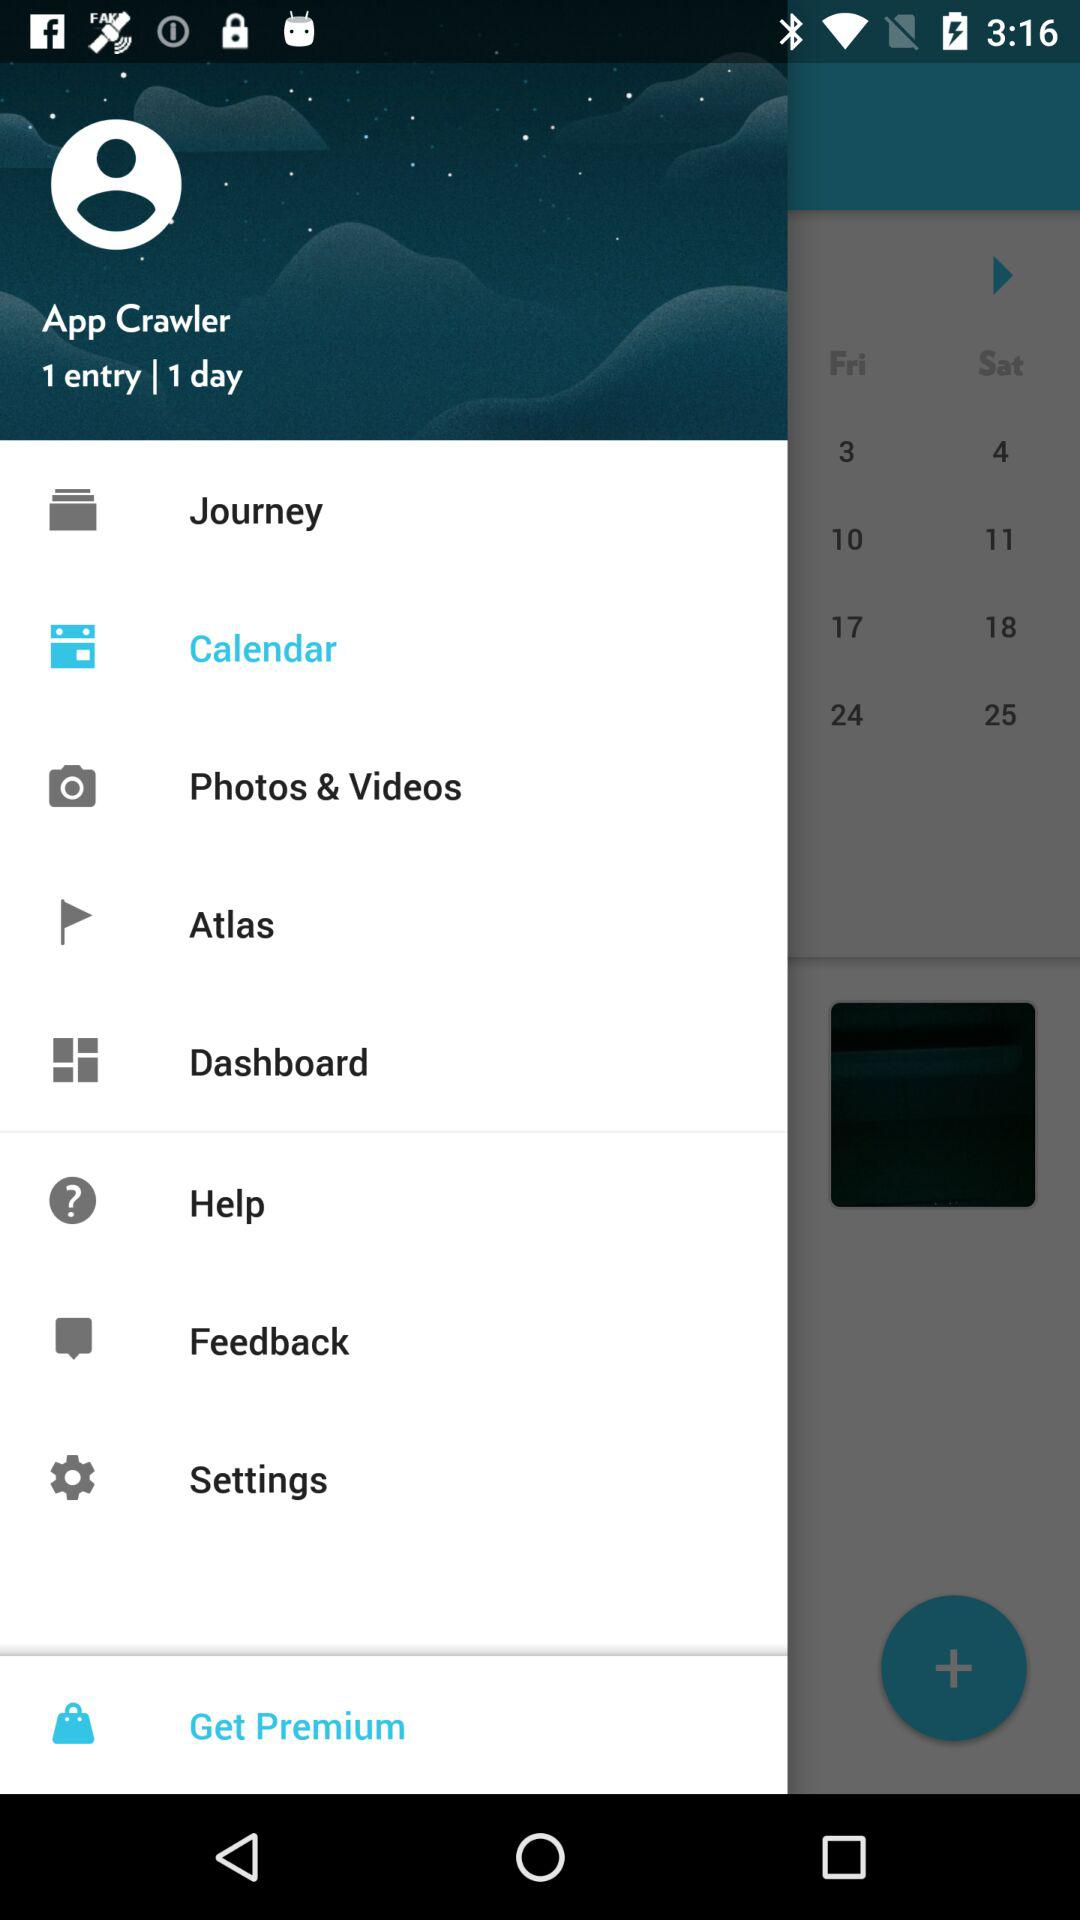What is the name of the user? The name of the user is App Crawler. 